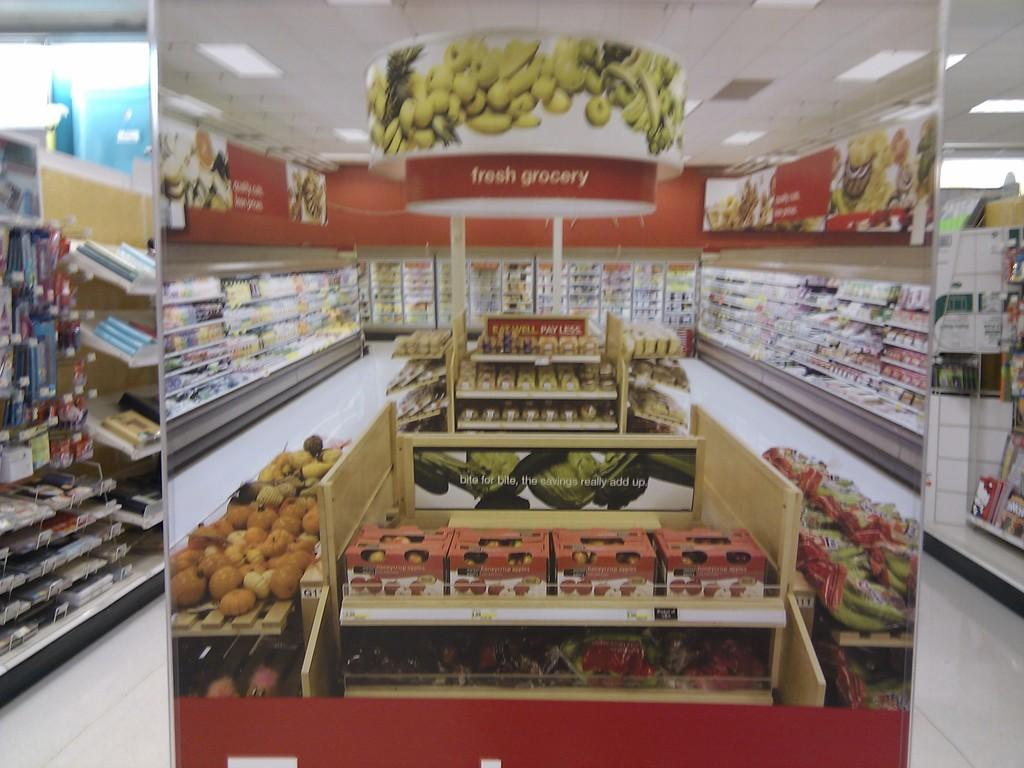Where was the image taken? The image was taken in a supermarket. What can be seen in the front of the image? There is a mirror in the front of the image. What is located to the left of the image? There are racks to the left of the image. What type of items can be seen in the racks? Fruits are visible in the racks, as seen in the mirror. Can you see any ships or horses in the image? No, there are no ships or horses present in the image. The image is taken in a supermarket, and the focus is on the mirror, racks, and fruits. 